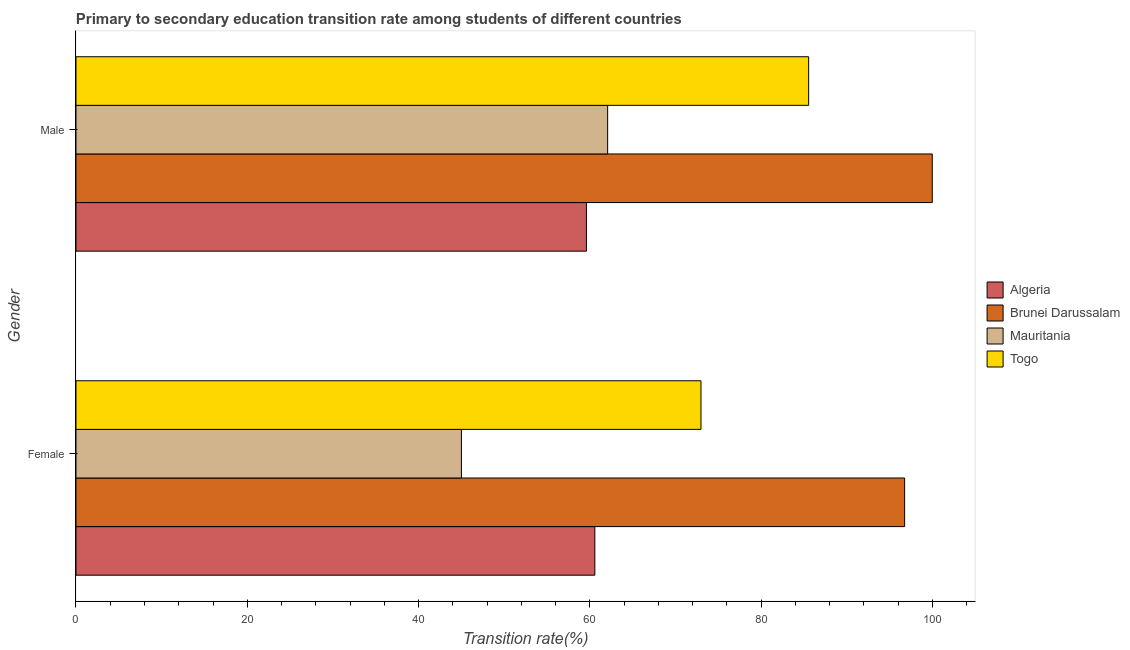How many different coloured bars are there?
Your response must be concise. 4. How many groups of bars are there?
Your response must be concise. 2. Are the number of bars on each tick of the Y-axis equal?
Make the answer very short. Yes. How many bars are there on the 2nd tick from the top?
Provide a succinct answer. 4. What is the label of the 1st group of bars from the top?
Make the answer very short. Male. What is the transition rate among female students in Brunei Darussalam?
Your answer should be very brief. 96.77. Across all countries, what is the maximum transition rate among female students?
Your answer should be very brief. 96.77. Across all countries, what is the minimum transition rate among female students?
Keep it short and to the point. 45.01. In which country was the transition rate among male students maximum?
Your answer should be very brief. Brunei Darussalam. In which country was the transition rate among female students minimum?
Keep it short and to the point. Mauritania. What is the total transition rate among female students in the graph?
Provide a succinct answer. 275.37. What is the difference between the transition rate among male students in Togo and that in Mauritania?
Give a very brief answer. 23.47. What is the difference between the transition rate among male students in Mauritania and the transition rate among female students in Algeria?
Offer a very short reply. 1.49. What is the average transition rate among male students per country?
Provide a short and direct response. 76.82. What is the difference between the transition rate among female students and transition rate among male students in Mauritania?
Make the answer very short. -17.07. What is the ratio of the transition rate among male students in Togo to that in Algeria?
Make the answer very short. 1.44. What does the 4th bar from the top in Female represents?
Keep it short and to the point. Algeria. What does the 3rd bar from the bottom in Male represents?
Make the answer very short. Mauritania. What is the difference between two consecutive major ticks on the X-axis?
Your response must be concise. 20. Are the values on the major ticks of X-axis written in scientific E-notation?
Offer a terse response. No. Does the graph contain any zero values?
Provide a short and direct response. No. What is the title of the graph?
Make the answer very short. Primary to secondary education transition rate among students of different countries. What is the label or title of the X-axis?
Your answer should be compact. Transition rate(%). What is the Transition rate(%) in Algeria in Female?
Give a very brief answer. 60.59. What is the Transition rate(%) in Brunei Darussalam in Female?
Offer a very short reply. 96.77. What is the Transition rate(%) of Mauritania in Female?
Make the answer very short. 45.01. What is the Transition rate(%) of Togo in Female?
Make the answer very short. 72.99. What is the Transition rate(%) in Algeria in Male?
Offer a terse response. 59.61. What is the Transition rate(%) in Brunei Darussalam in Male?
Ensure brevity in your answer.  100. What is the Transition rate(%) of Mauritania in Male?
Provide a short and direct response. 62.09. What is the Transition rate(%) in Togo in Male?
Give a very brief answer. 85.56. Across all Gender, what is the maximum Transition rate(%) in Algeria?
Your answer should be compact. 60.59. Across all Gender, what is the maximum Transition rate(%) in Brunei Darussalam?
Ensure brevity in your answer.  100. Across all Gender, what is the maximum Transition rate(%) in Mauritania?
Offer a terse response. 62.09. Across all Gender, what is the maximum Transition rate(%) of Togo?
Your answer should be compact. 85.56. Across all Gender, what is the minimum Transition rate(%) of Algeria?
Provide a succinct answer. 59.61. Across all Gender, what is the minimum Transition rate(%) in Brunei Darussalam?
Make the answer very short. 96.77. Across all Gender, what is the minimum Transition rate(%) in Mauritania?
Offer a very short reply. 45.01. Across all Gender, what is the minimum Transition rate(%) of Togo?
Make the answer very short. 72.99. What is the total Transition rate(%) in Algeria in the graph?
Make the answer very short. 120.21. What is the total Transition rate(%) of Brunei Darussalam in the graph?
Offer a terse response. 196.77. What is the total Transition rate(%) of Mauritania in the graph?
Keep it short and to the point. 107.1. What is the total Transition rate(%) of Togo in the graph?
Provide a short and direct response. 158.55. What is the difference between the Transition rate(%) of Algeria in Female and that in Male?
Give a very brief answer. 0.98. What is the difference between the Transition rate(%) in Brunei Darussalam in Female and that in Male?
Provide a short and direct response. -3.23. What is the difference between the Transition rate(%) of Mauritania in Female and that in Male?
Offer a very short reply. -17.07. What is the difference between the Transition rate(%) of Togo in Female and that in Male?
Your response must be concise. -12.57. What is the difference between the Transition rate(%) in Algeria in Female and the Transition rate(%) in Brunei Darussalam in Male?
Provide a succinct answer. -39.41. What is the difference between the Transition rate(%) of Algeria in Female and the Transition rate(%) of Mauritania in Male?
Give a very brief answer. -1.49. What is the difference between the Transition rate(%) of Algeria in Female and the Transition rate(%) of Togo in Male?
Provide a succinct answer. -24.97. What is the difference between the Transition rate(%) in Brunei Darussalam in Female and the Transition rate(%) in Mauritania in Male?
Offer a terse response. 34.68. What is the difference between the Transition rate(%) in Brunei Darussalam in Female and the Transition rate(%) in Togo in Male?
Provide a short and direct response. 11.21. What is the difference between the Transition rate(%) in Mauritania in Female and the Transition rate(%) in Togo in Male?
Your answer should be compact. -40.55. What is the average Transition rate(%) in Algeria per Gender?
Keep it short and to the point. 60.1. What is the average Transition rate(%) of Brunei Darussalam per Gender?
Provide a short and direct response. 98.39. What is the average Transition rate(%) in Mauritania per Gender?
Your answer should be compact. 53.55. What is the average Transition rate(%) of Togo per Gender?
Provide a succinct answer. 79.28. What is the difference between the Transition rate(%) in Algeria and Transition rate(%) in Brunei Darussalam in Female?
Your answer should be very brief. -36.18. What is the difference between the Transition rate(%) of Algeria and Transition rate(%) of Mauritania in Female?
Give a very brief answer. 15.58. What is the difference between the Transition rate(%) in Algeria and Transition rate(%) in Togo in Female?
Provide a succinct answer. -12.4. What is the difference between the Transition rate(%) in Brunei Darussalam and Transition rate(%) in Mauritania in Female?
Offer a terse response. 51.76. What is the difference between the Transition rate(%) in Brunei Darussalam and Transition rate(%) in Togo in Female?
Keep it short and to the point. 23.78. What is the difference between the Transition rate(%) of Mauritania and Transition rate(%) of Togo in Female?
Make the answer very short. -27.97. What is the difference between the Transition rate(%) of Algeria and Transition rate(%) of Brunei Darussalam in Male?
Provide a succinct answer. -40.39. What is the difference between the Transition rate(%) of Algeria and Transition rate(%) of Mauritania in Male?
Offer a terse response. -2.47. What is the difference between the Transition rate(%) in Algeria and Transition rate(%) in Togo in Male?
Your answer should be very brief. -25.95. What is the difference between the Transition rate(%) in Brunei Darussalam and Transition rate(%) in Mauritania in Male?
Keep it short and to the point. 37.91. What is the difference between the Transition rate(%) of Brunei Darussalam and Transition rate(%) of Togo in Male?
Offer a terse response. 14.44. What is the difference between the Transition rate(%) in Mauritania and Transition rate(%) in Togo in Male?
Provide a succinct answer. -23.47. What is the ratio of the Transition rate(%) of Algeria in Female to that in Male?
Provide a succinct answer. 1.02. What is the ratio of the Transition rate(%) of Mauritania in Female to that in Male?
Keep it short and to the point. 0.72. What is the ratio of the Transition rate(%) in Togo in Female to that in Male?
Your answer should be very brief. 0.85. What is the difference between the highest and the second highest Transition rate(%) in Algeria?
Make the answer very short. 0.98. What is the difference between the highest and the second highest Transition rate(%) of Brunei Darussalam?
Provide a short and direct response. 3.23. What is the difference between the highest and the second highest Transition rate(%) of Mauritania?
Your answer should be compact. 17.07. What is the difference between the highest and the second highest Transition rate(%) of Togo?
Ensure brevity in your answer.  12.57. What is the difference between the highest and the lowest Transition rate(%) of Algeria?
Offer a terse response. 0.98. What is the difference between the highest and the lowest Transition rate(%) of Brunei Darussalam?
Offer a very short reply. 3.23. What is the difference between the highest and the lowest Transition rate(%) of Mauritania?
Give a very brief answer. 17.07. What is the difference between the highest and the lowest Transition rate(%) of Togo?
Ensure brevity in your answer.  12.57. 